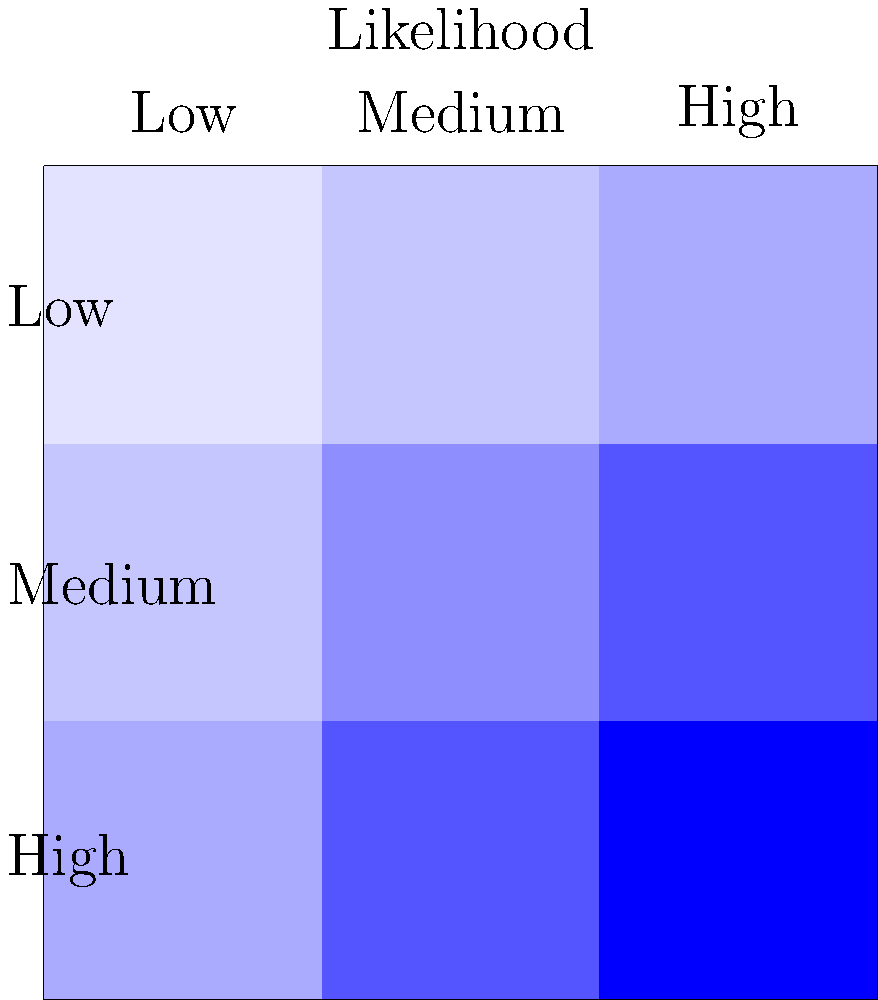As a new business owner, you're assessing potential risks using the risk matrix shown above. If your company faces a medium likelihood event with a high impact, and your total assets are valued at $500,000, what is the potential financial loss based on the risk score? To solve this problem, we'll follow these steps:

1. Identify the risk score:
   - Medium likelihood is the middle row
   - High impact is the right column
   - The intersection gives us a risk score of 6

2. Interpret the risk score:
   - The risk matrix uses a 1-9 scale
   - A score of 6 indicates a relatively high risk

3. Calculate the potential financial loss:
   - We can interpret the risk score as a percentage of total assets at risk
   - Risk percentage = (Risk score / Maximum score) * 100%
   - Risk percentage = (6 / 9) * 100% = 66.67%

4. Apply the risk percentage to total assets:
   - Potential loss = Total assets * Risk percentage
   - Potential loss = $500,000 * 66.67%
   - Potential loss = $333,350

Therefore, based on the risk matrix and the company's total asset value, the potential financial loss for a medium likelihood, high impact event is $333,350.
Answer: $333,350 